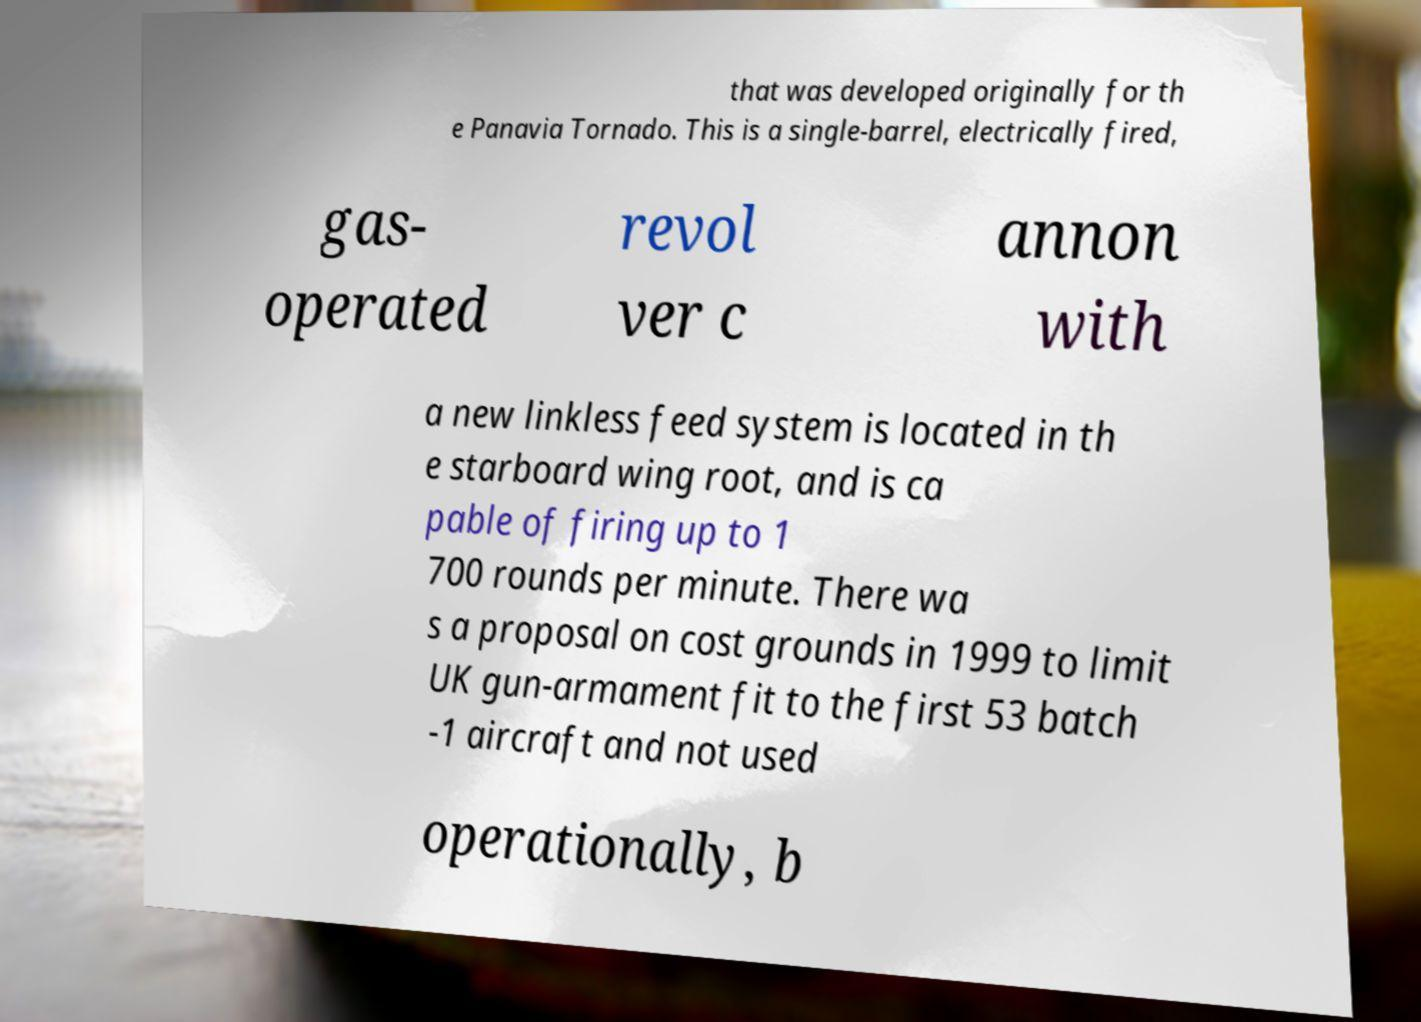I need the written content from this picture converted into text. Can you do that? that was developed originally for th e Panavia Tornado. This is a single-barrel, electrically fired, gas- operated revol ver c annon with a new linkless feed system is located in th e starboard wing root, and is ca pable of firing up to 1 700 rounds per minute. There wa s a proposal on cost grounds in 1999 to limit UK gun-armament fit to the first 53 batch -1 aircraft and not used operationally, b 